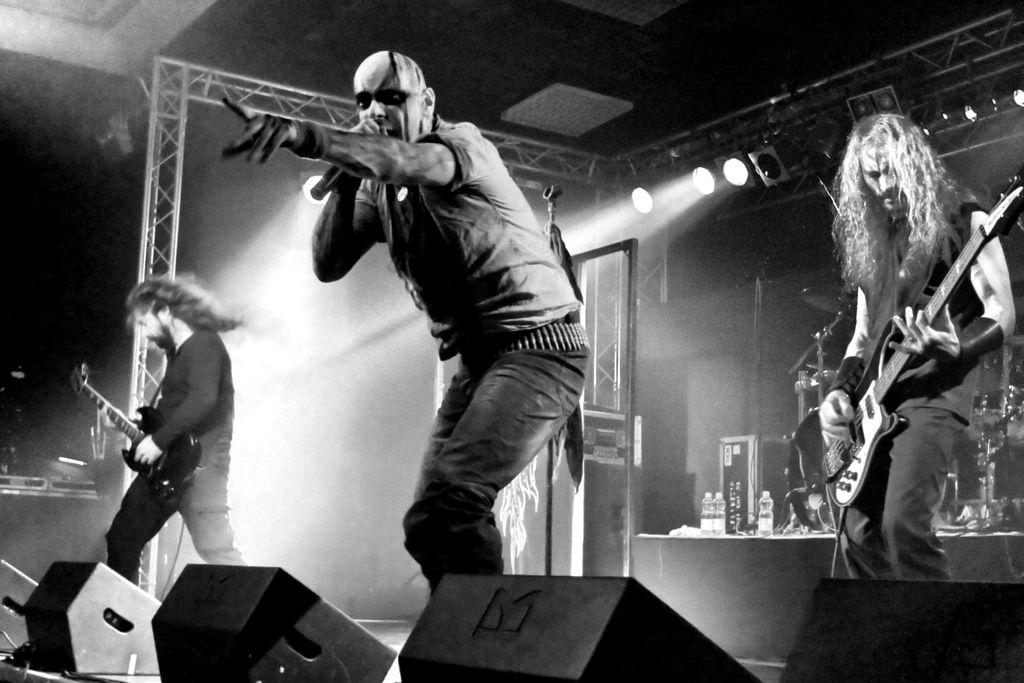How many men are in the image? There are three men in the image. What are two of the men doing? Two of the men are playing guitars. What is the third man doing? The third man is singing into a microphone. What can be seen in the background of the image? There are lights, pillars, bottles, and speakers visible in the background. How many centimeters of earthquake damage can be seen in the image? There is no earthquake damage present in the image. How many cats are visible in the image? There are no cats present in the image. 